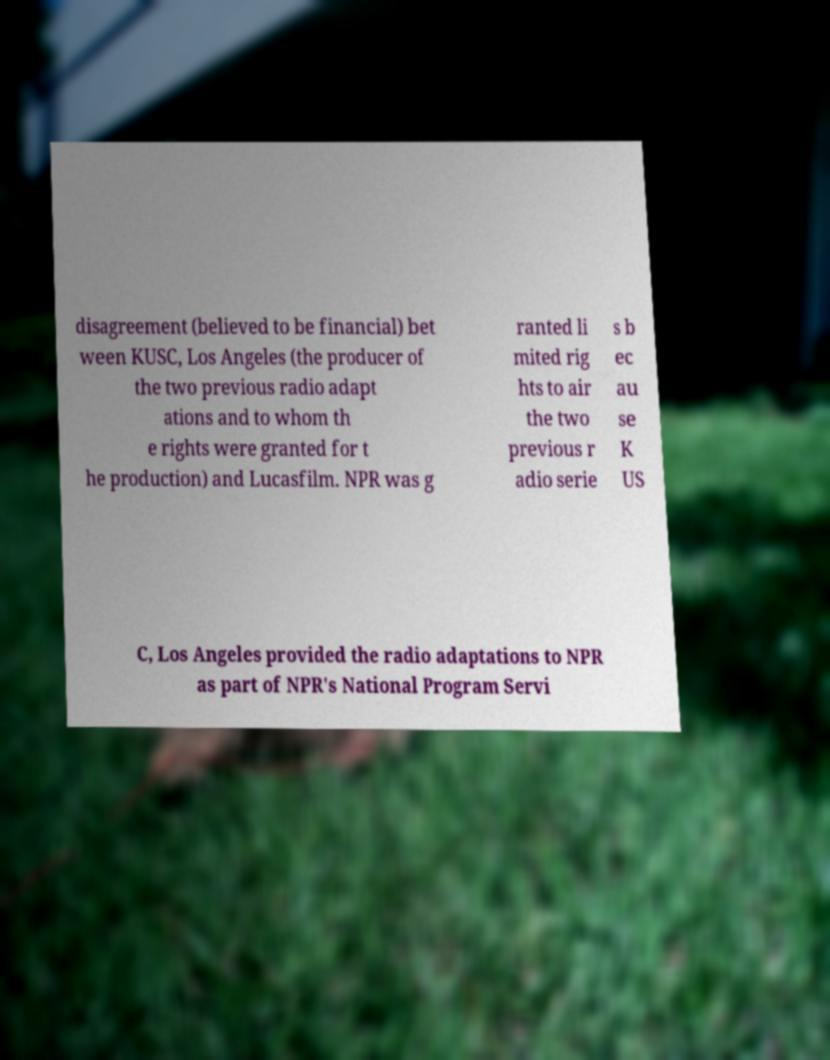Could you extract and type out the text from this image? disagreement (believed to be financial) bet ween KUSC, Los Angeles (the producer of the two previous radio adapt ations and to whom th e rights were granted for t he production) and Lucasfilm. NPR was g ranted li mited rig hts to air the two previous r adio serie s b ec au se K US C, Los Angeles provided the radio adaptations to NPR as part of NPR's National Program Servi 